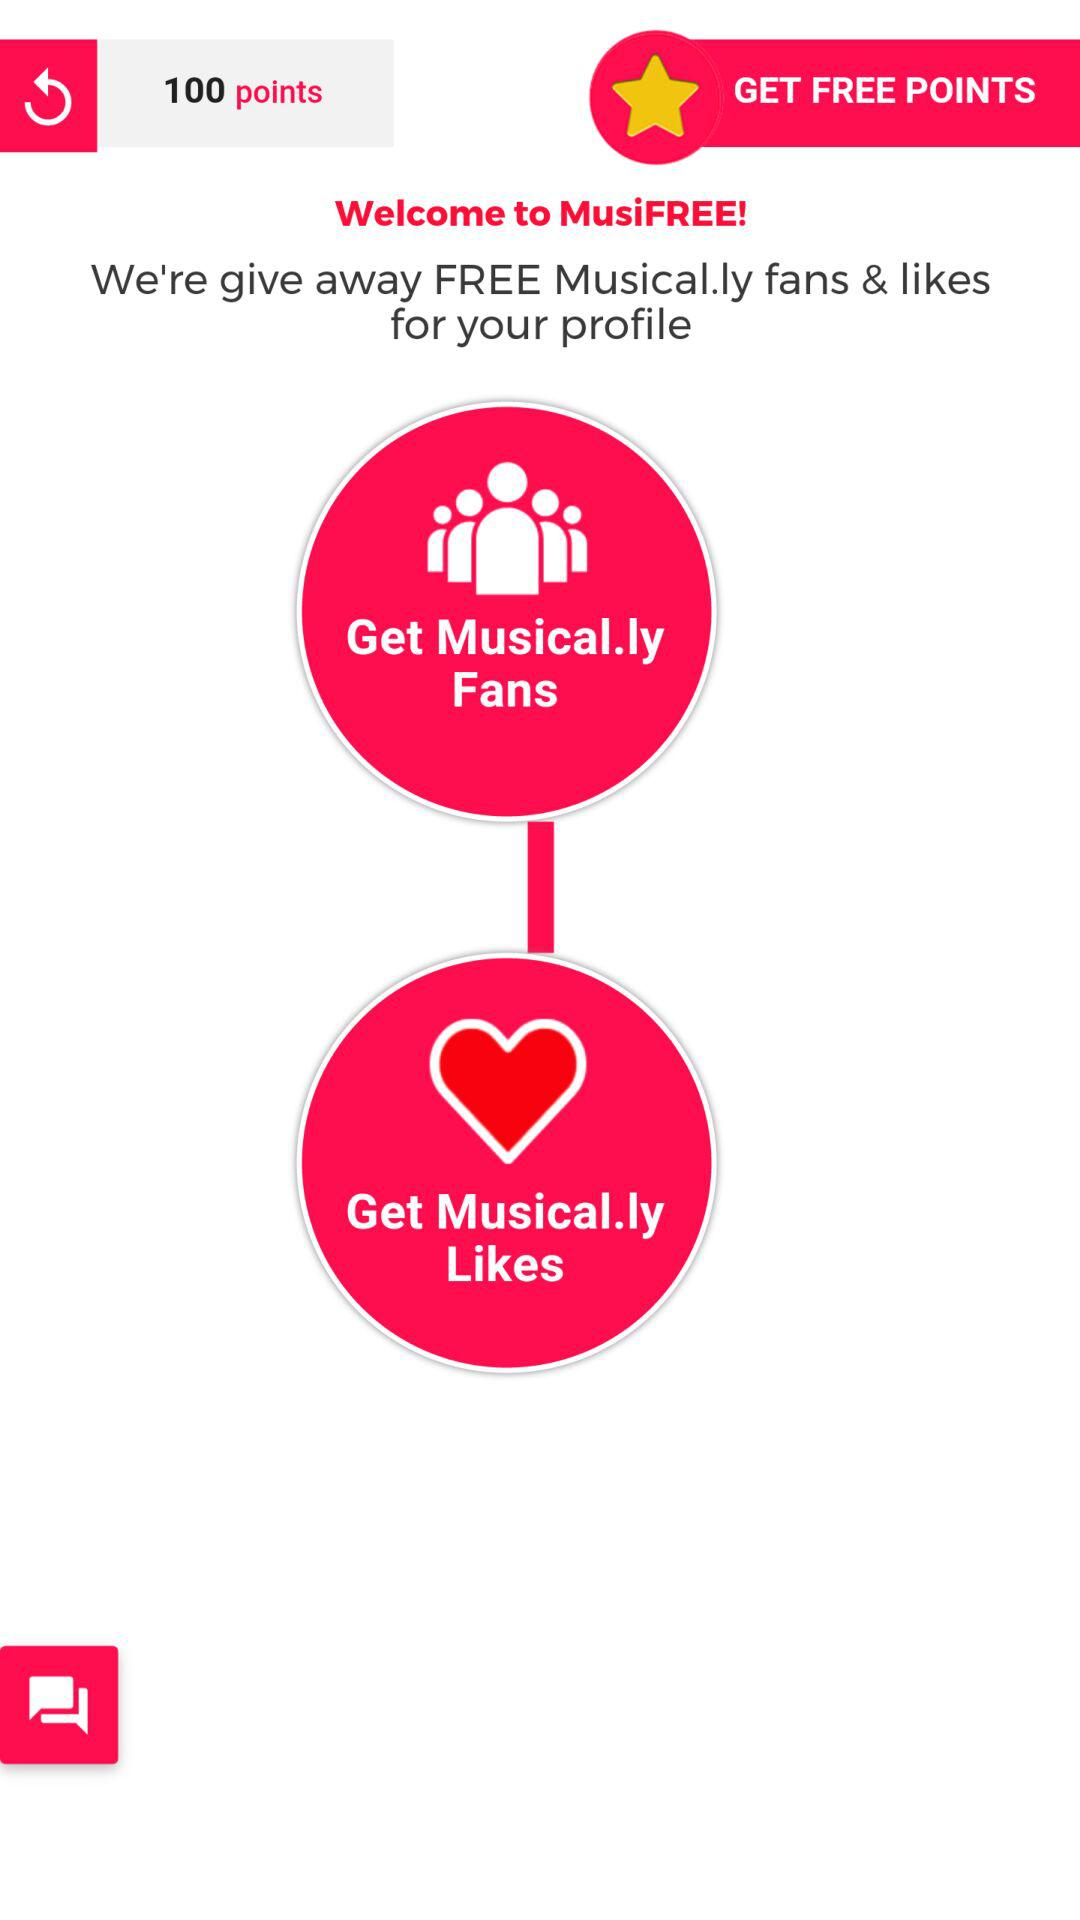What are the total points? The total points are 100. 